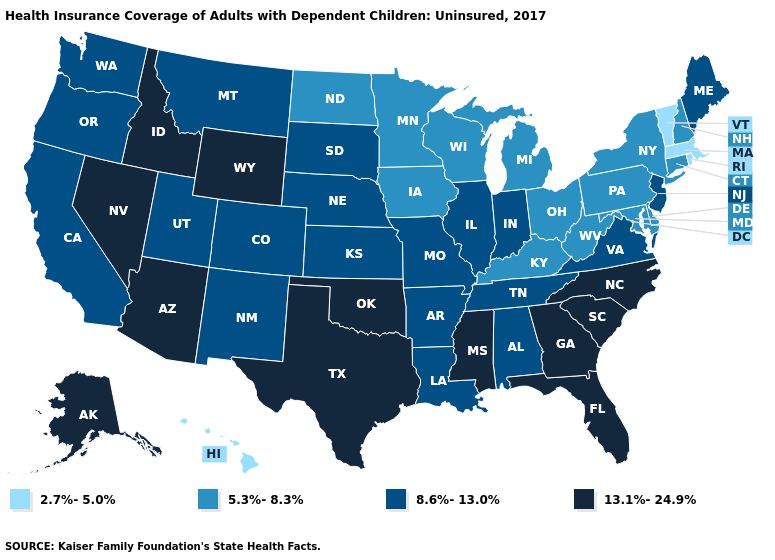What is the value of Louisiana?
Concise answer only. 8.6%-13.0%. Name the states that have a value in the range 13.1%-24.9%?
Keep it brief. Alaska, Arizona, Florida, Georgia, Idaho, Mississippi, Nevada, North Carolina, Oklahoma, South Carolina, Texas, Wyoming. Name the states that have a value in the range 8.6%-13.0%?
Give a very brief answer. Alabama, Arkansas, California, Colorado, Illinois, Indiana, Kansas, Louisiana, Maine, Missouri, Montana, Nebraska, New Jersey, New Mexico, Oregon, South Dakota, Tennessee, Utah, Virginia, Washington. Does Delaware have the lowest value in the South?
Quick response, please. Yes. What is the highest value in the Northeast ?
Write a very short answer. 8.6%-13.0%. Does the first symbol in the legend represent the smallest category?
Concise answer only. Yes. What is the lowest value in the USA?
Keep it brief. 2.7%-5.0%. Is the legend a continuous bar?
Short answer required. No. Name the states that have a value in the range 5.3%-8.3%?
Answer briefly. Connecticut, Delaware, Iowa, Kentucky, Maryland, Michigan, Minnesota, New Hampshire, New York, North Dakota, Ohio, Pennsylvania, West Virginia, Wisconsin. What is the value of Georgia?
Short answer required. 13.1%-24.9%. Does Indiana have a higher value than Wisconsin?
Be succinct. Yes. Name the states that have a value in the range 8.6%-13.0%?
Short answer required. Alabama, Arkansas, California, Colorado, Illinois, Indiana, Kansas, Louisiana, Maine, Missouri, Montana, Nebraska, New Jersey, New Mexico, Oregon, South Dakota, Tennessee, Utah, Virginia, Washington. Which states have the lowest value in the USA?
Concise answer only. Hawaii, Massachusetts, Rhode Island, Vermont. Name the states that have a value in the range 5.3%-8.3%?
Answer briefly. Connecticut, Delaware, Iowa, Kentucky, Maryland, Michigan, Minnesota, New Hampshire, New York, North Dakota, Ohio, Pennsylvania, West Virginia, Wisconsin. What is the value of Michigan?
Give a very brief answer. 5.3%-8.3%. 